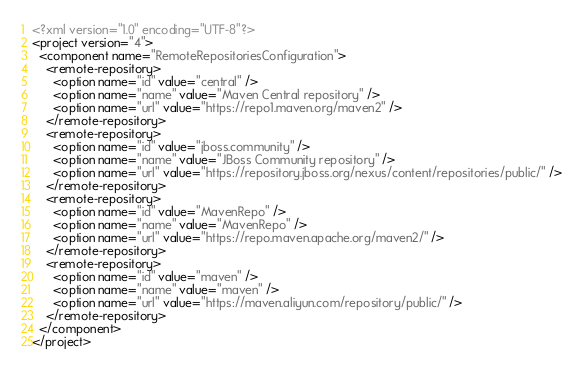<code> <loc_0><loc_0><loc_500><loc_500><_XML_><?xml version="1.0" encoding="UTF-8"?>
<project version="4">
  <component name="RemoteRepositoriesConfiguration">
    <remote-repository>
      <option name="id" value="central" />
      <option name="name" value="Maven Central repository" />
      <option name="url" value="https://repo1.maven.org/maven2" />
    </remote-repository>
    <remote-repository>
      <option name="id" value="jboss.community" />
      <option name="name" value="JBoss Community repository" />
      <option name="url" value="https://repository.jboss.org/nexus/content/repositories/public/" />
    </remote-repository>
    <remote-repository>
      <option name="id" value="MavenRepo" />
      <option name="name" value="MavenRepo" />
      <option name="url" value="https://repo.maven.apache.org/maven2/" />
    </remote-repository>
    <remote-repository>
      <option name="id" value="maven" />
      <option name="name" value="maven" />
      <option name="url" value="https://maven.aliyun.com/repository/public/" />
    </remote-repository>
  </component>
</project></code> 